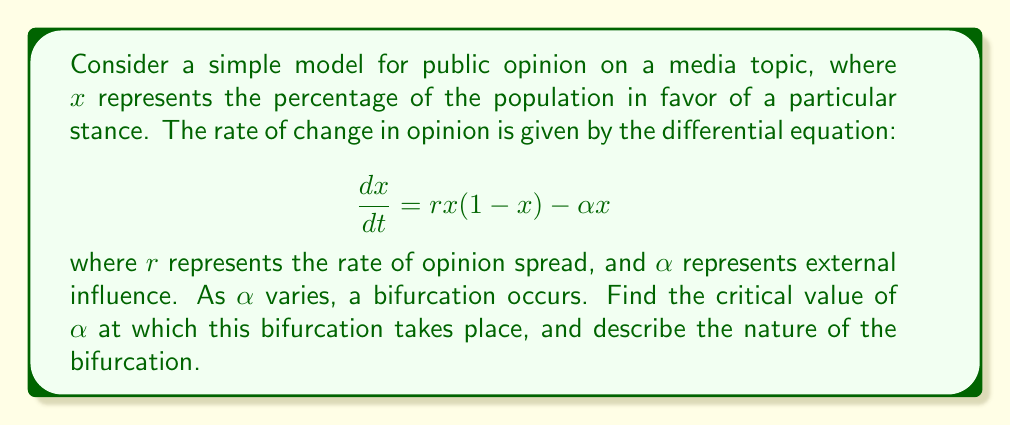What is the answer to this math problem? To analyze this bifurcation:

1) First, find the equilibrium points by setting $\frac{dx}{dt} = 0$:

   $$rx(1-x) - \alpha x = 0$$
   $$x(r(1-x) - \alpha) = 0$$

2) This gives us two equilibrium points:
   $x_1 = 0$ and $x_2 = 1 - \frac{\alpha}{r}$

3) For $x_2$ to be meaningful (between 0 and 1), we need $0 < 1 - \frac{\alpha}{r} < 1$, or $0 < \alpha < r$.

4) To determine stability, we calculate $\frac{d}{dx}(\frac{dx}{dt})$ at each equilibrium point:

   $$\frac{d}{dx}(\frac{dx}{dt}) = r(1-2x) - \alpha$$

5) At $x_1 = 0$: $r - \alpha$
   At $x_2 = 1 - \frac{\alpha}{r}$: $-(r - \alpha)$

6) The bifurcation occurs when the stability of $x_1$ changes, i.e., when $r - \alpha = 0$ or $\alpha = r$.

7) When $\alpha < r$, $x_1$ is unstable and $x_2$ is stable.
   When $\alpha > r$, $x_1$ is stable and $x_2$ doesn't exist in $[0,1]$.

8) This describes a transcritical bifurcation, where the two equilibrium points exchange stability at $\alpha = r$.
Answer: Critical value: $\alpha = r$; Transcritical bifurcation 